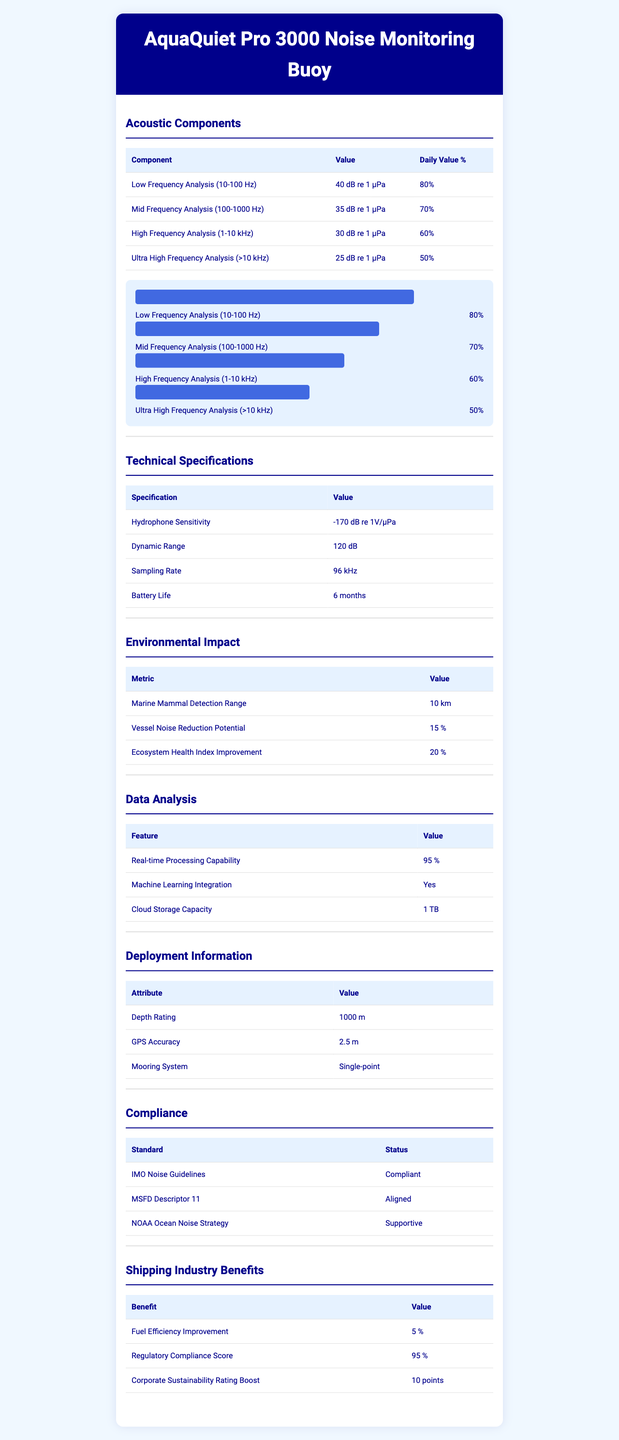what is the serving size for the AquaQuiet Pro 3000 Noise Monitoring Buoy? The serving size is specified in the document under "serving size" as 1 buoy deployment.
Answer: 1 buoy deployment how many servings are there per container of the AquaQuiet Pro 3000? The document specifies that there is 1 serving per container under "servings per container."
Answer: 1 what is the value of Low Frequency Analysis (10-100 Hz) in dB re 1 µPa? The value for Low Frequency Analysis (10-100 Hz) is listed in the document under "Acoustic Components" as 40 dB re 1 µPa.
Answer: 40 dB re 1 µPa what is the daily value percentage for High Frequency Analysis (1-10 kHz)? The daily value percentage for High Frequency Analysis (1-10 kHz) is specified in the document as 60%.
Answer: 60% what is the Hydrophone Sensitivity in dB re 1V/µPa? The Hydrophone Sensitivity is listed under "Technical Specifications" as -170 dB re 1V/µPa.
Answer: -170 dB re 1V/µPa what is the Marine Mammal Detection Range? The Marine Mammal Detection Range is listed under "Environmental Impact" as 10 km.
Answer: 10 km what is the Cloud Storage Capacity of the AquaQuiet Pro 3000? The Cloud Storage Capacity is listed under "Data Analysis" as 1 TB.
Answer: 1 TB which frequency analysis component has the highest daily value percentage? A. Low Frequency Analysis B. Mid Frequency Analysis C. High Frequency Analysis D. Ultra High Frequency Analysis The daily value percentages are 80% for Low Frequency Analysis, 70% for Mid Frequency Analysis, 60% for High Frequency Analysis, and 50% for Ultra High Frequency Analysis. Therefore, Low Frequency Analysis has the highest percentage.
Answer: A. Low Frequency Analysis what is the Dynamic Range of the AquaQuiet Pro 3000? A. 100 dB B. 110 dB C. 120 dB D. 130 dB The document lists the Dynamic Range under "Technical Specifications" as 120 dB.
Answer: C. 120 dB is the AquaQuiet Pro 3000 compliant with IMO Noise Guidelines? The document specifies under "Compliance" that the AquaQuiet Pro 3000 is compliant with IMO Noise Guidelines.
Answer: Yes describe the main features of the AquaQuiet Pro 3000 Noise Monitoring Buoy. This description aggregates information from all sections provided in the document, touching upon Acoustic Components, Technical Specifications, Environmental Impact, Data Analysis, Deployment Information, and Compliance.
Answer: The AquaQuiet Pro 3000 Noise Monitoring Buoy offers a range of acoustic analysis including Low, Mid, High, and Ultra High Frequency Analysis. It has advanced technical specifications like Hydrophone Sensitivity of -170 dB re 1V/µPa, a Dynamic Range of 120 dB, and a Sampling Rate of 96 kHz. The buoy impacts environmental health, detecting marine mammals up to 10 km away and improving ecosystem health by 20%. It also supports real-time data analysis and machine learning, has a depth rating of 1000 m, and complies with multiple standards like IMO Noise Guidelines. how long does the battery of the AquaQuiet Pro 3000 last? The document specifies the Battery Life under "Technical Specifications" as 6 months.
Answer: 6 months how much is the Vessel Noise Reduction Potential? The Vessel Noise Reduction Potential is listed under "Environmental Impact" as 15%.
Answer: 15% does the AquaQuiet Pro 3000 incorporate machine learning? The inclusion of Machine Learning Integration is specified under "Data Analysis" as Yes.
Answer: Yes did the document provide the manufacturer of the AquaQuiet Pro 3000? The document does not contain any information about the manufacturer of the AquaQuiet Pro 3000.
Answer: Not enough information 